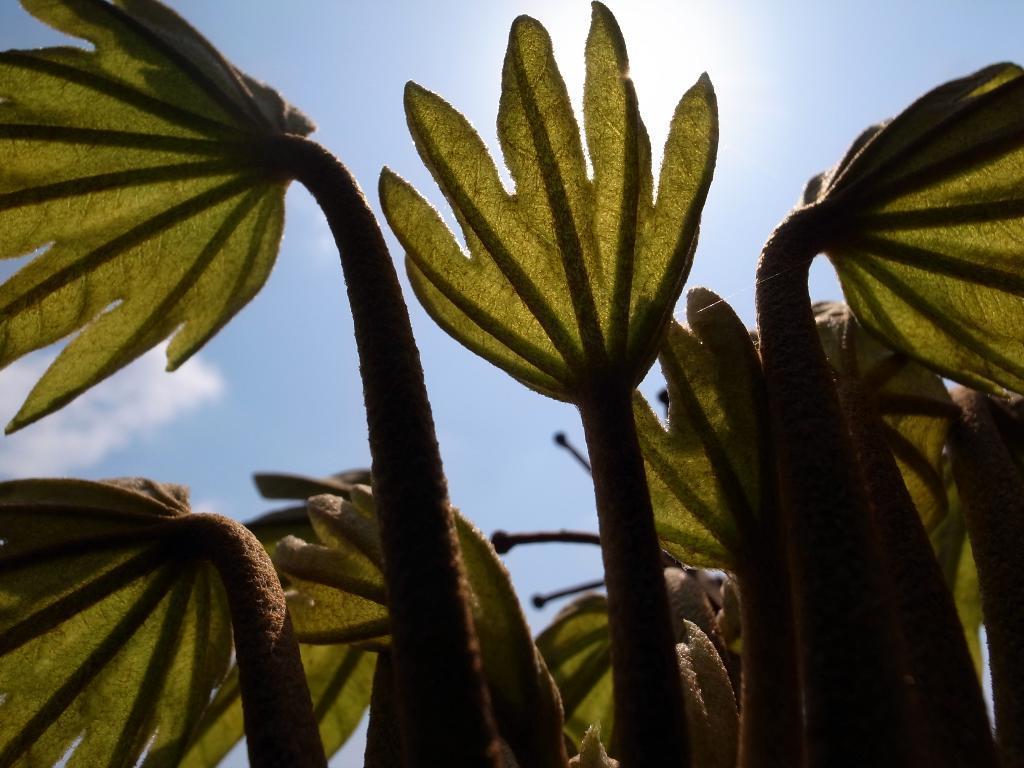In one or two sentences, can you explain what this image depicts? In the picture I can see green color leaves. In the background, I can see the blue color sky with clouds. 